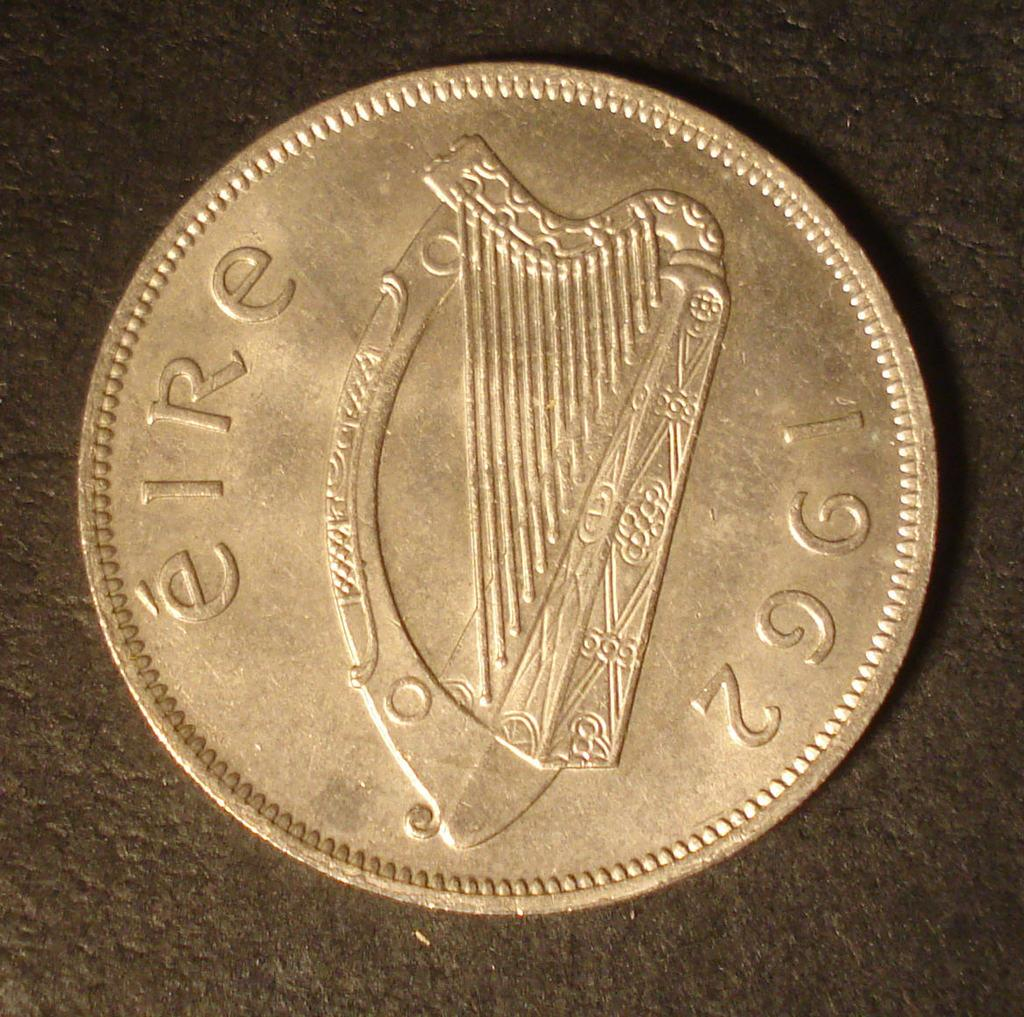What is located in the foreground of the image? There is a coin in the foreground of the image. What is written on the coin? The coin has "harps," "1962," and "eire" printed on it. What type of guitar is being played by the visitor in the image? There is no visitor or guitar present in the image; it only features a coin. 